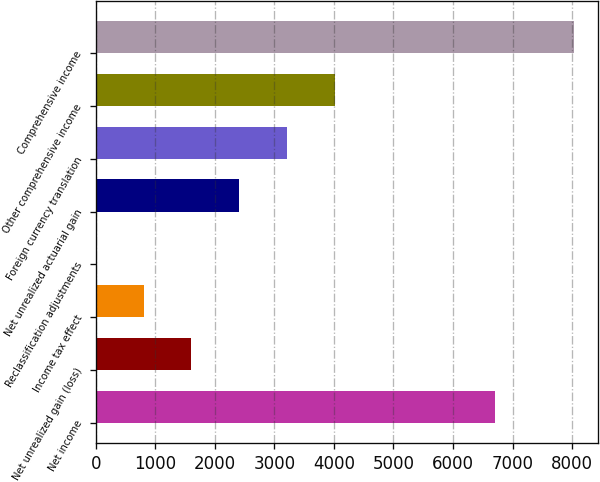<chart> <loc_0><loc_0><loc_500><loc_500><bar_chart><fcel>Net income<fcel>Net unrealized gain (loss)<fcel>Income tax effect<fcel>Reclassification adjustments<fcel>Net unrealized actuarial gain<fcel>Foreign currency translation<fcel>Other comprehensive income<fcel>Comprehensive income<nl><fcel>6699<fcel>1607.8<fcel>804.4<fcel>1<fcel>2411.2<fcel>3214.6<fcel>4018<fcel>8035<nl></chart> 